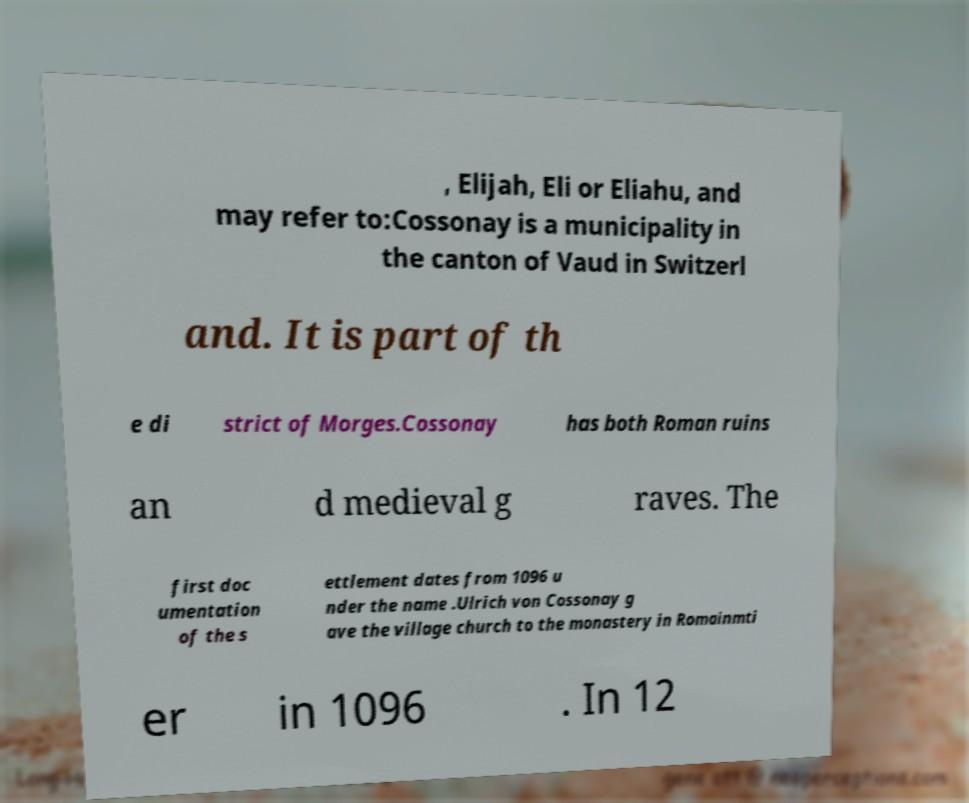Could you extract and type out the text from this image? , Elijah, Eli or Eliahu, and may refer to:Cossonay is a municipality in the canton of Vaud in Switzerl and. It is part of th e di strict of Morges.Cossonay has both Roman ruins an d medieval g raves. The first doc umentation of the s ettlement dates from 1096 u nder the name .Ulrich von Cossonay g ave the village church to the monastery in Romainmti er in 1096 . In 12 